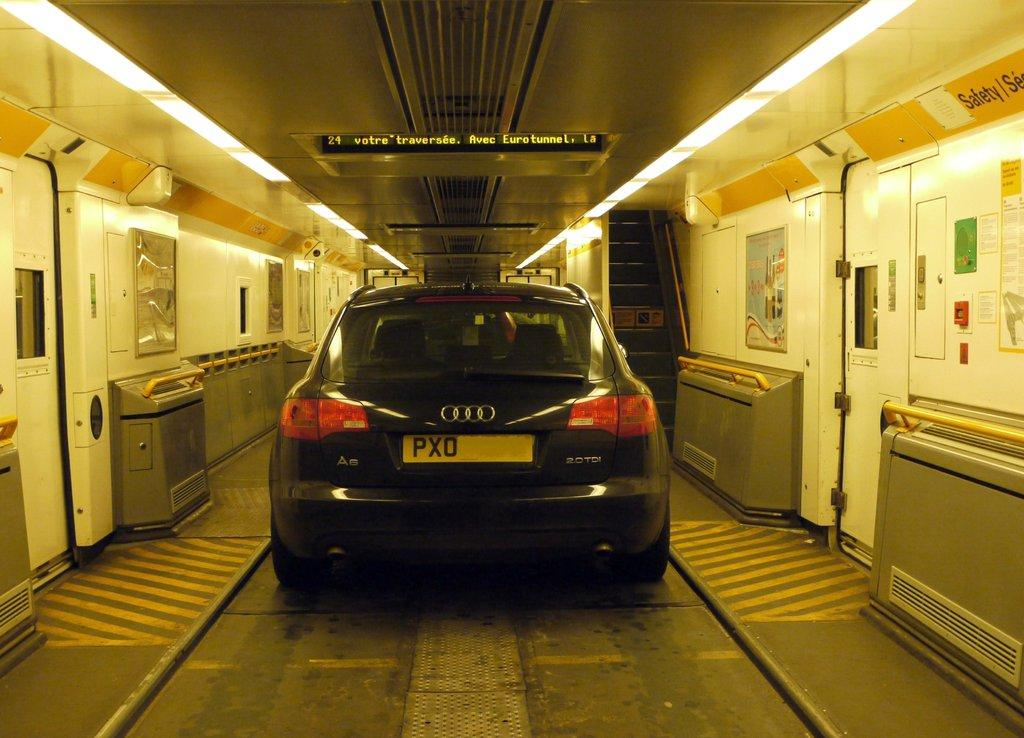What is the main subject in the center of the image? There is a car in the center of the image. What is located at the bottom of the image? There is a road at the bottom of the image. What part of the car can be seen in the image? There are doors visible in the image. What is located at the top of the image? There are lights at the top of the image. What architectural feature is visible in the image? There are stairs visible in the image. Can you tell me how many times the car was kicked in the image? There is no indication in the image that the car was kicked, so it cannot be determined from the picture. 